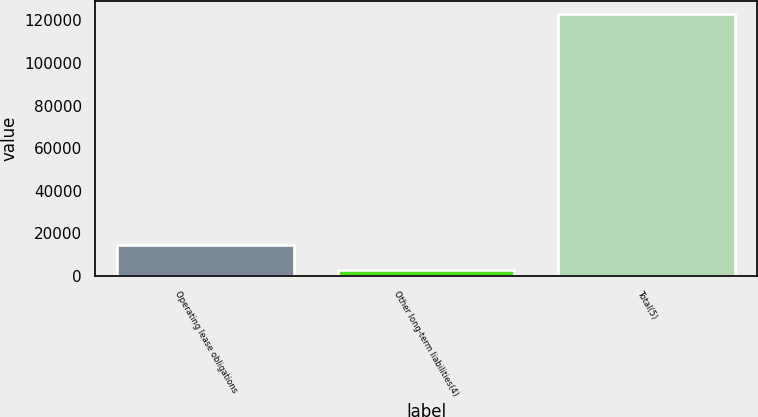Convert chart to OTSL. <chart><loc_0><loc_0><loc_500><loc_500><bar_chart><fcel>Operating lease obligations<fcel>Other long-term liabilities(4)<fcel>Total(5)<nl><fcel>14711<fcel>2683<fcel>122963<nl></chart> 